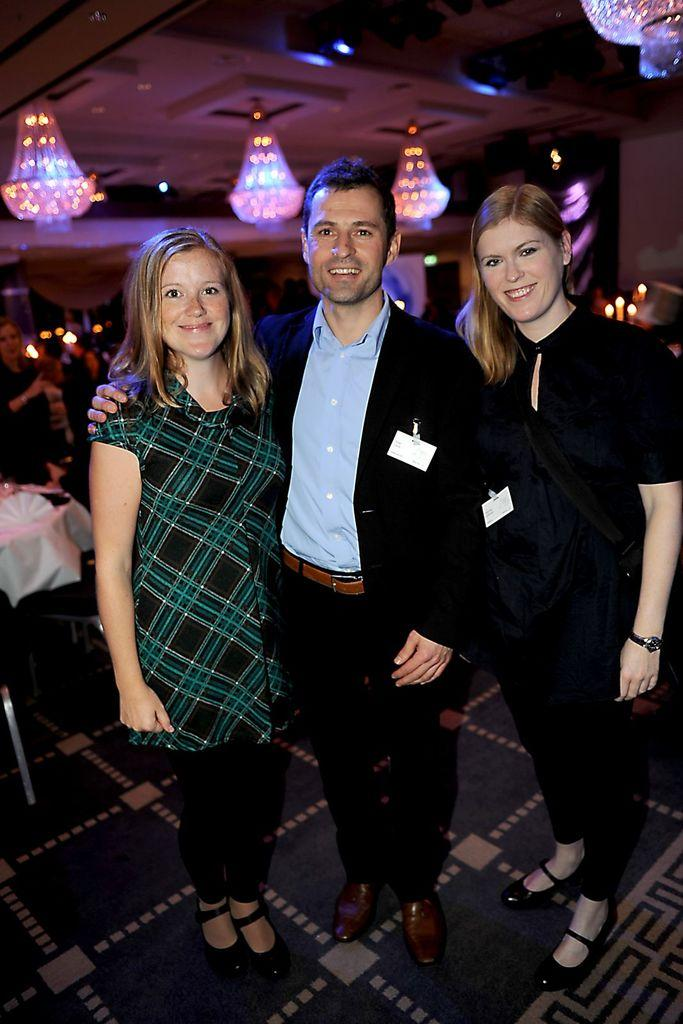What type of lighting fixture is present in the image? There are chandeliers in the image. Are there any individuals visible in the image? Yes, there are people in the image. What color dresses are some of the people wearing? Some people in the image are wearing black color dresses. What type of cloud can be seen in the image? There is no cloud present in the image; it features chandeliers and people. How does the chandelier stop functioning in the image? The chandelier does not stop functioning in the image; it is stationary and illuminated. 